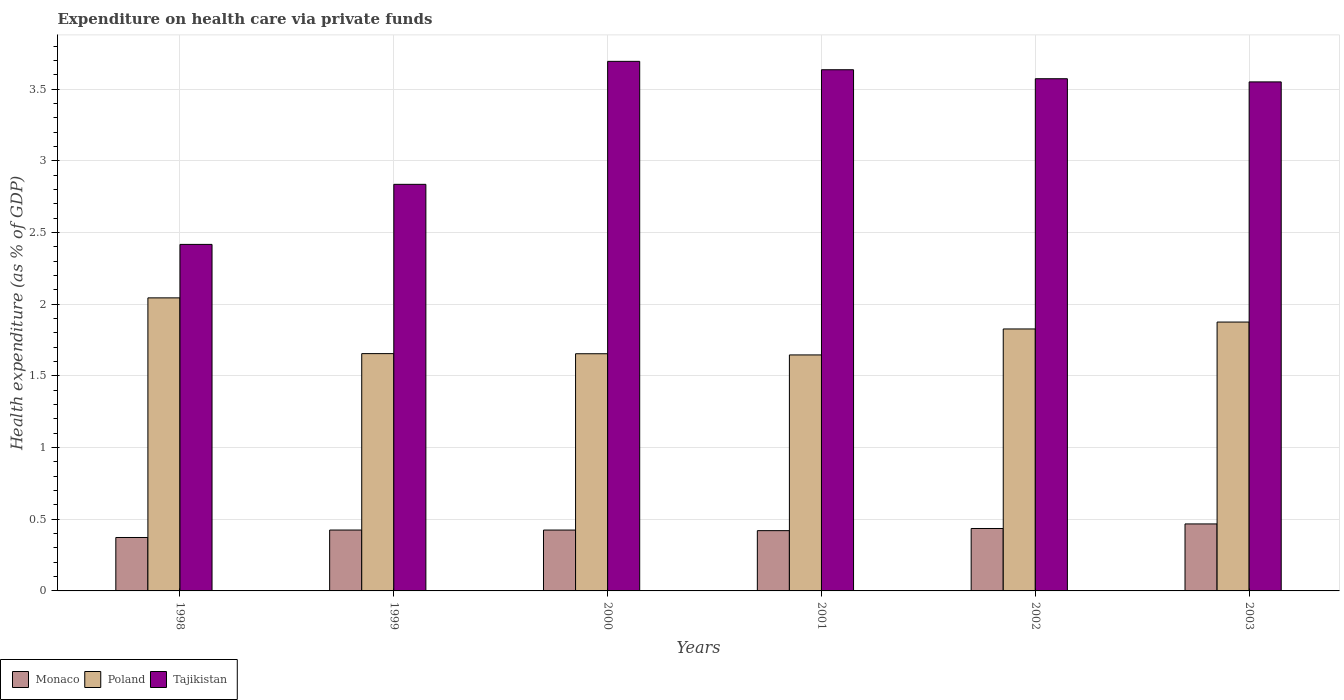How many groups of bars are there?
Your answer should be compact. 6. Are the number of bars per tick equal to the number of legend labels?
Ensure brevity in your answer.  Yes. Are the number of bars on each tick of the X-axis equal?
Give a very brief answer. Yes. How many bars are there on the 2nd tick from the right?
Your answer should be compact. 3. In how many cases, is the number of bars for a given year not equal to the number of legend labels?
Give a very brief answer. 0. What is the expenditure made on health care in Tajikistan in 2002?
Your response must be concise. 3.57. Across all years, what is the maximum expenditure made on health care in Poland?
Your answer should be very brief. 2.04. Across all years, what is the minimum expenditure made on health care in Tajikistan?
Your response must be concise. 2.42. In which year was the expenditure made on health care in Poland minimum?
Offer a terse response. 2001. What is the total expenditure made on health care in Monaco in the graph?
Offer a terse response. 2.55. What is the difference between the expenditure made on health care in Tajikistan in 1999 and that in 2000?
Your response must be concise. -0.86. What is the difference between the expenditure made on health care in Monaco in 2000 and the expenditure made on health care in Tajikistan in 1999?
Your response must be concise. -2.41. What is the average expenditure made on health care in Tajikistan per year?
Make the answer very short. 3.28. In the year 2001, what is the difference between the expenditure made on health care in Tajikistan and expenditure made on health care in Poland?
Your response must be concise. 1.99. In how many years, is the expenditure made on health care in Tajikistan greater than 0.8 %?
Your answer should be compact. 6. What is the ratio of the expenditure made on health care in Poland in 1999 to that in 2001?
Offer a very short reply. 1.01. Is the difference between the expenditure made on health care in Tajikistan in 2000 and 2001 greater than the difference between the expenditure made on health care in Poland in 2000 and 2001?
Your answer should be very brief. Yes. What is the difference between the highest and the second highest expenditure made on health care in Poland?
Your answer should be very brief. 0.17. What is the difference between the highest and the lowest expenditure made on health care in Tajikistan?
Your answer should be very brief. 1.28. In how many years, is the expenditure made on health care in Tajikistan greater than the average expenditure made on health care in Tajikistan taken over all years?
Keep it short and to the point. 4. Is the sum of the expenditure made on health care in Poland in 1999 and 2002 greater than the maximum expenditure made on health care in Tajikistan across all years?
Keep it short and to the point. No. What does the 1st bar from the left in 2000 represents?
Offer a terse response. Monaco. What does the 1st bar from the right in 1998 represents?
Your answer should be compact. Tajikistan. Are all the bars in the graph horizontal?
Give a very brief answer. No. How many years are there in the graph?
Your answer should be very brief. 6. What is the difference between two consecutive major ticks on the Y-axis?
Your answer should be very brief. 0.5. How are the legend labels stacked?
Ensure brevity in your answer.  Horizontal. What is the title of the graph?
Provide a succinct answer. Expenditure on health care via private funds. Does "Romania" appear as one of the legend labels in the graph?
Provide a succinct answer. No. What is the label or title of the X-axis?
Offer a very short reply. Years. What is the label or title of the Y-axis?
Offer a very short reply. Health expenditure (as % of GDP). What is the Health expenditure (as % of GDP) in Monaco in 1998?
Your response must be concise. 0.37. What is the Health expenditure (as % of GDP) of Poland in 1998?
Offer a very short reply. 2.04. What is the Health expenditure (as % of GDP) of Tajikistan in 1998?
Your response must be concise. 2.42. What is the Health expenditure (as % of GDP) of Monaco in 1999?
Make the answer very short. 0.42. What is the Health expenditure (as % of GDP) of Poland in 1999?
Provide a short and direct response. 1.66. What is the Health expenditure (as % of GDP) of Tajikistan in 1999?
Your answer should be very brief. 2.84. What is the Health expenditure (as % of GDP) of Monaco in 2000?
Provide a succinct answer. 0.42. What is the Health expenditure (as % of GDP) in Poland in 2000?
Offer a very short reply. 1.65. What is the Health expenditure (as % of GDP) of Tajikistan in 2000?
Offer a terse response. 3.69. What is the Health expenditure (as % of GDP) in Monaco in 2001?
Offer a very short reply. 0.42. What is the Health expenditure (as % of GDP) of Poland in 2001?
Keep it short and to the point. 1.65. What is the Health expenditure (as % of GDP) in Tajikistan in 2001?
Provide a short and direct response. 3.64. What is the Health expenditure (as % of GDP) in Monaco in 2002?
Make the answer very short. 0.44. What is the Health expenditure (as % of GDP) of Poland in 2002?
Your answer should be compact. 1.83. What is the Health expenditure (as % of GDP) of Tajikistan in 2002?
Your answer should be compact. 3.57. What is the Health expenditure (as % of GDP) of Monaco in 2003?
Your response must be concise. 0.47. What is the Health expenditure (as % of GDP) in Poland in 2003?
Your answer should be compact. 1.88. What is the Health expenditure (as % of GDP) in Tajikistan in 2003?
Make the answer very short. 3.55. Across all years, what is the maximum Health expenditure (as % of GDP) of Monaco?
Provide a short and direct response. 0.47. Across all years, what is the maximum Health expenditure (as % of GDP) of Poland?
Offer a terse response. 2.04. Across all years, what is the maximum Health expenditure (as % of GDP) of Tajikistan?
Ensure brevity in your answer.  3.69. Across all years, what is the minimum Health expenditure (as % of GDP) in Monaco?
Ensure brevity in your answer.  0.37. Across all years, what is the minimum Health expenditure (as % of GDP) of Poland?
Make the answer very short. 1.65. Across all years, what is the minimum Health expenditure (as % of GDP) in Tajikistan?
Provide a short and direct response. 2.42. What is the total Health expenditure (as % of GDP) of Monaco in the graph?
Give a very brief answer. 2.55. What is the total Health expenditure (as % of GDP) in Poland in the graph?
Provide a short and direct response. 10.7. What is the total Health expenditure (as % of GDP) of Tajikistan in the graph?
Give a very brief answer. 19.71. What is the difference between the Health expenditure (as % of GDP) of Monaco in 1998 and that in 1999?
Give a very brief answer. -0.05. What is the difference between the Health expenditure (as % of GDP) of Poland in 1998 and that in 1999?
Offer a terse response. 0.39. What is the difference between the Health expenditure (as % of GDP) of Tajikistan in 1998 and that in 1999?
Offer a terse response. -0.42. What is the difference between the Health expenditure (as % of GDP) in Monaco in 1998 and that in 2000?
Your answer should be very brief. -0.05. What is the difference between the Health expenditure (as % of GDP) in Poland in 1998 and that in 2000?
Keep it short and to the point. 0.39. What is the difference between the Health expenditure (as % of GDP) of Tajikistan in 1998 and that in 2000?
Offer a very short reply. -1.28. What is the difference between the Health expenditure (as % of GDP) in Monaco in 1998 and that in 2001?
Your response must be concise. -0.05. What is the difference between the Health expenditure (as % of GDP) of Poland in 1998 and that in 2001?
Offer a very short reply. 0.4. What is the difference between the Health expenditure (as % of GDP) of Tajikistan in 1998 and that in 2001?
Your response must be concise. -1.22. What is the difference between the Health expenditure (as % of GDP) in Monaco in 1998 and that in 2002?
Give a very brief answer. -0.06. What is the difference between the Health expenditure (as % of GDP) in Poland in 1998 and that in 2002?
Offer a terse response. 0.22. What is the difference between the Health expenditure (as % of GDP) in Tajikistan in 1998 and that in 2002?
Your response must be concise. -1.16. What is the difference between the Health expenditure (as % of GDP) in Monaco in 1998 and that in 2003?
Offer a terse response. -0.09. What is the difference between the Health expenditure (as % of GDP) in Poland in 1998 and that in 2003?
Provide a succinct answer. 0.17. What is the difference between the Health expenditure (as % of GDP) of Tajikistan in 1998 and that in 2003?
Your answer should be very brief. -1.13. What is the difference between the Health expenditure (as % of GDP) of Monaco in 1999 and that in 2000?
Offer a very short reply. 0. What is the difference between the Health expenditure (as % of GDP) of Poland in 1999 and that in 2000?
Ensure brevity in your answer.  0. What is the difference between the Health expenditure (as % of GDP) in Tajikistan in 1999 and that in 2000?
Make the answer very short. -0.86. What is the difference between the Health expenditure (as % of GDP) of Monaco in 1999 and that in 2001?
Provide a short and direct response. 0. What is the difference between the Health expenditure (as % of GDP) of Poland in 1999 and that in 2001?
Provide a succinct answer. 0.01. What is the difference between the Health expenditure (as % of GDP) of Tajikistan in 1999 and that in 2001?
Make the answer very short. -0.8. What is the difference between the Health expenditure (as % of GDP) in Monaco in 1999 and that in 2002?
Ensure brevity in your answer.  -0.01. What is the difference between the Health expenditure (as % of GDP) of Poland in 1999 and that in 2002?
Offer a terse response. -0.17. What is the difference between the Health expenditure (as % of GDP) of Tajikistan in 1999 and that in 2002?
Provide a short and direct response. -0.74. What is the difference between the Health expenditure (as % of GDP) in Monaco in 1999 and that in 2003?
Your response must be concise. -0.04. What is the difference between the Health expenditure (as % of GDP) of Poland in 1999 and that in 2003?
Your response must be concise. -0.22. What is the difference between the Health expenditure (as % of GDP) in Tajikistan in 1999 and that in 2003?
Keep it short and to the point. -0.71. What is the difference between the Health expenditure (as % of GDP) in Monaco in 2000 and that in 2001?
Keep it short and to the point. 0. What is the difference between the Health expenditure (as % of GDP) of Poland in 2000 and that in 2001?
Your response must be concise. 0.01. What is the difference between the Health expenditure (as % of GDP) in Tajikistan in 2000 and that in 2001?
Offer a terse response. 0.06. What is the difference between the Health expenditure (as % of GDP) of Monaco in 2000 and that in 2002?
Provide a succinct answer. -0.01. What is the difference between the Health expenditure (as % of GDP) in Poland in 2000 and that in 2002?
Make the answer very short. -0.17. What is the difference between the Health expenditure (as % of GDP) in Tajikistan in 2000 and that in 2002?
Ensure brevity in your answer.  0.12. What is the difference between the Health expenditure (as % of GDP) of Monaco in 2000 and that in 2003?
Give a very brief answer. -0.04. What is the difference between the Health expenditure (as % of GDP) of Poland in 2000 and that in 2003?
Provide a short and direct response. -0.22. What is the difference between the Health expenditure (as % of GDP) in Tajikistan in 2000 and that in 2003?
Keep it short and to the point. 0.14. What is the difference between the Health expenditure (as % of GDP) in Monaco in 2001 and that in 2002?
Offer a terse response. -0.01. What is the difference between the Health expenditure (as % of GDP) of Poland in 2001 and that in 2002?
Your answer should be very brief. -0.18. What is the difference between the Health expenditure (as % of GDP) of Tajikistan in 2001 and that in 2002?
Ensure brevity in your answer.  0.06. What is the difference between the Health expenditure (as % of GDP) of Monaco in 2001 and that in 2003?
Offer a terse response. -0.05. What is the difference between the Health expenditure (as % of GDP) in Poland in 2001 and that in 2003?
Keep it short and to the point. -0.23. What is the difference between the Health expenditure (as % of GDP) of Tajikistan in 2001 and that in 2003?
Make the answer very short. 0.08. What is the difference between the Health expenditure (as % of GDP) of Monaco in 2002 and that in 2003?
Give a very brief answer. -0.03. What is the difference between the Health expenditure (as % of GDP) of Poland in 2002 and that in 2003?
Provide a succinct answer. -0.05. What is the difference between the Health expenditure (as % of GDP) of Tajikistan in 2002 and that in 2003?
Offer a very short reply. 0.02. What is the difference between the Health expenditure (as % of GDP) in Monaco in 1998 and the Health expenditure (as % of GDP) in Poland in 1999?
Give a very brief answer. -1.28. What is the difference between the Health expenditure (as % of GDP) in Monaco in 1998 and the Health expenditure (as % of GDP) in Tajikistan in 1999?
Provide a short and direct response. -2.46. What is the difference between the Health expenditure (as % of GDP) of Poland in 1998 and the Health expenditure (as % of GDP) of Tajikistan in 1999?
Your answer should be very brief. -0.79. What is the difference between the Health expenditure (as % of GDP) in Monaco in 1998 and the Health expenditure (as % of GDP) in Poland in 2000?
Make the answer very short. -1.28. What is the difference between the Health expenditure (as % of GDP) of Monaco in 1998 and the Health expenditure (as % of GDP) of Tajikistan in 2000?
Your response must be concise. -3.32. What is the difference between the Health expenditure (as % of GDP) in Poland in 1998 and the Health expenditure (as % of GDP) in Tajikistan in 2000?
Offer a very short reply. -1.65. What is the difference between the Health expenditure (as % of GDP) of Monaco in 1998 and the Health expenditure (as % of GDP) of Poland in 2001?
Your answer should be very brief. -1.27. What is the difference between the Health expenditure (as % of GDP) of Monaco in 1998 and the Health expenditure (as % of GDP) of Tajikistan in 2001?
Offer a very short reply. -3.26. What is the difference between the Health expenditure (as % of GDP) of Poland in 1998 and the Health expenditure (as % of GDP) of Tajikistan in 2001?
Give a very brief answer. -1.59. What is the difference between the Health expenditure (as % of GDP) of Monaco in 1998 and the Health expenditure (as % of GDP) of Poland in 2002?
Keep it short and to the point. -1.45. What is the difference between the Health expenditure (as % of GDP) in Monaco in 1998 and the Health expenditure (as % of GDP) in Tajikistan in 2002?
Your response must be concise. -3.2. What is the difference between the Health expenditure (as % of GDP) of Poland in 1998 and the Health expenditure (as % of GDP) of Tajikistan in 2002?
Offer a terse response. -1.53. What is the difference between the Health expenditure (as % of GDP) of Monaco in 1998 and the Health expenditure (as % of GDP) of Poland in 2003?
Offer a very short reply. -1.5. What is the difference between the Health expenditure (as % of GDP) in Monaco in 1998 and the Health expenditure (as % of GDP) in Tajikistan in 2003?
Keep it short and to the point. -3.18. What is the difference between the Health expenditure (as % of GDP) in Poland in 1998 and the Health expenditure (as % of GDP) in Tajikistan in 2003?
Provide a succinct answer. -1.51. What is the difference between the Health expenditure (as % of GDP) in Monaco in 1999 and the Health expenditure (as % of GDP) in Poland in 2000?
Your answer should be compact. -1.23. What is the difference between the Health expenditure (as % of GDP) of Monaco in 1999 and the Health expenditure (as % of GDP) of Tajikistan in 2000?
Provide a succinct answer. -3.27. What is the difference between the Health expenditure (as % of GDP) of Poland in 1999 and the Health expenditure (as % of GDP) of Tajikistan in 2000?
Your response must be concise. -2.04. What is the difference between the Health expenditure (as % of GDP) in Monaco in 1999 and the Health expenditure (as % of GDP) in Poland in 2001?
Provide a short and direct response. -1.22. What is the difference between the Health expenditure (as % of GDP) of Monaco in 1999 and the Health expenditure (as % of GDP) of Tajikistan in 2001?
Provide a succinct answer. -3.21. What is the difference between the Health expenditure (as % of GDP) of Poland in 1999 and the Health expenditure (as % of GDP) of Tajikistan in 2001?
Provide a short and direct response. -1.98. What is the difference between the Health expenditure (as % of GDP) in Monaco in 1999 and the Health expenditure (as % of GDP) in Poland in 2002?
Give a very brief answer. -1.4. What is the difference between the Health expenditure (as % of GDP) in Monaco in 1999 and the Health expenditure (as % of GDP) in Tajikistan in 2002?
Your answer should be compact. -3.15. What is the difference between the Health expenditure (as % of GDP) in Poland in 1999 and the Health expenditure (as % of GDP) in Tajikistan in 2002?
Your answer should be compact. -1.92. What is the difference between the Health expenditure (as % of GDP) in Monaco in 1999 and the Health expenditure (as % of GDP) in Poland in 2003?
Provide a short and direct response. -1.45. What is the difference between the Health expenditure (as % of GDP) in Monaco in 1999 and the Health expenditure (as % of GDP) in Tajikistan in 2003?
Your answer should be very brief. -3.13. What is the difference between the Health expenditure (as % of GDP) in Poland in 1999 and the Health expenditure (as % of GDP) in Tajikistan in 2003?
Give a very brief answer. -1.9. What is the difference between the Health expenditure (as % of GDP) of Monaco in 2000 and the Health expenditure (as % of GDP) of Poland in 2001?
Offer a terse response. -1.22. What is the difference between the Health expenditure (as % of GDP) in Monaco in 2000 and the Health expenditure (as % of GDP) in Tajikistan in 2001?
Provide a succinct answer. -3.21. What is the difference between the Health expenditure (as % of GDP) of Poland in 2000 and the Health expenditure (as % of GDP) of Tajikistan in 2001?
Provide a succinct answer. -1.98. What is the difference between the Health expenditure (as % of GDP) in Monaco in 2000 and the Health expenditure (as % of GDP) in Poland in 2002?
Give a very brief answer. -1.4. What is the difference between the Health expenditure (as % of GDP) in Monaco in 2000 and the Health expenditure (as % of GDP) in Tajikistan in 2002?
Make the answer very short. -3.15. What is the difference between the Health expenditure (as % of GDP) of Poland in 2000 and the Health expenditure (as % of GDP) of Tajikistan in 2002?
Provide a short and direct response. -1.92. What is the difference between the Health expenditure (as % of GDP) of Monaco in 2000 and the Health expenditure (as % of GDP) of Poland in 2003?
Your answer should be very brief. -1.45. What is the difference between the Health expenditure (as % of GDP) in Monaco in 2000 and the Health expenditure (as % of GDP) in Tajikistan in 2003?
Provide a short and direct response. -3.13. What is the difference between the Health expenditure (as % of GDP) of Poland in 2000 and the Health expenditure (as % of GDP) of Tajikistan in 2003?
Give a very brief answer. -1.9. What is the difference between the Health expenditure (as % of GDP) of Monaco in 2001 and the Health expenditure (as % of GDP) of Poland in 2002?
Your answer should be very brief. -1.41. What is the difference between the Health expenditure (as % of GDP) of Monaco in 2001 and the Health expenditure (as % of GDP) of Tajikistan in 2002?
Your answer should be compact. -3.15. What is the difference between the Health expenditure (as % of GDP) in Poland in 2001 and the Health expenditure (as % of GDP) in Tajikistan in 2002?
Offer a very short reply. -1.93. What is the difference between the Health expenditure (as % of GDP) in Monaco in 2001 and the Health expenditure (as % of GDP) in Poland in 2003?
Your answer should be compact. -1.46. What is the difference between the Health expenditure (as % of GDP) in Monaco in 2001 and the Health expenditure (as % of GDP) in Tajikistan in 2003?
Provide a short and direct response. -3.13. What is the difference between the Health expenditure (as % of GDP) in Poland in 2001 and the Health expenditure (as % of GDP) in Tajikistan in 2003?
Your response must be concise. -1.9. What is the difference between the Health expenditure (as % of GDP) of Monaco in 2002 and the Health expenditure (as % of GDP) of Poland in 2003?
Give a very brief answer. -1.44. What is the difference between the Health expenditure (as % of GDP) in Monaco in 2002 and the Health expenditure (as % of GDP) in Tajikistan in 2003?
Ensure brevity in your answer.  -3.12. What is the difference between the Health expenditure (as % of GDP) of Poland in 2002 and the Health expenditure (as % of GDP) of Tajikistan in 2003?
Provide a short and direct response. -1.72. What is the average Health expenditure (as % of GDP) of Monaco per year?
Provide a succinct answer. 0.42. What is the average Health expenditure (as % of GDP) of Poland per year?
Offer a very short reply. 1.78. What is the average Health expenditure (as % of GDP) in Tajikistan per year?
Keep it short and to the point. 3.28. In the year 1998, what is the difference between the Health expenditure (as % of GDP) of Monaco and Health expenditure (as % of GDP) of Poland?
Give a very brief answer. -1.67. In the year 1998, what is the difference between the Health expenditure (as % of GDP) in Monaco and Health expenditure (as % of GDP) in Tajikistan?
Your answer should be compact. -2.04. In the year 1998, what is the difference between the Health expenditure (as % of GDP) in Poland and Health expenditure (as % of GDP) in Tajikistan?
Keep it short and to the point. -0.37. In the year 1999, what is the difference between the Health expenditure (as % of GDP) of Monaco and Health expenditure (as % of GDP) of Poland?
Make the answer very short. -1.23. In the year 1999, what is the difference between the Health expenditure (as % of GDP) in Monaco and Health expenditure (as % of GDP) in Tajikistan?
Offer a terse response. -2.41. In the year 1999, what is the difference between the Health expenditure (as % of GDP) of Poland and Health expenditure (as % of GDP) of Tajikistan?
Your response must be concise. -1.18. In the year 2000, what is the difference between the Health expenditure (as % of GDP) in Monaco and Health expenditure (as % of GDP) in Poland?
Your response must be concise. -1.23. In the year 2000, what is the difference between the Health expenditure (as % of GDP) of Monaco and Health expenditure (as % of GDP) of Tajikistan?
Offer a terse response. -3.27. In the year 2000, what is the difference between the Health expenditure (as % of GDP) of Poland and Health expenditure (as % of GDP) of Tajikistan?
Make the answer very short. -2.04. In the year 2001, what is the difference between the Health expenditure (as % of GDP) in Monaco and Health expenditure (as % of GDP) in Poland?
Ensure brevity in your answer.  -1.23. In the year 2001, what is the difference between the Health expenditure (as % of GDP) of Monaco and Health expenditure (as % of GDP) of Tajikistan?
Make the answer very short. -3.22. In the year 2001, what is the difference between the Health expenditure (as % of GDP) in Poland and Health expenditure (as % of GDP) in Tajikistan?
Ensure brevity in your answer.  -1.99. In the year 2002, what is the difference between the Health expenditure (as % of GDP) in Monaco and Health expenditure (as % of GDP) in Poland?
Keep it short and to the point. -1.39. In the year 2002, what is the difference between the Health expenditure (as % of GDP) in Monaco and Health expenditure (as % of GDP) in Tajikistan?
Offer a very short reply. -3.14. In the year 2002, what is the difference between the Health expenditure (as % of GDP) of Poland and Health expenditure (as % of GDP) of Tajikistan?
Make the answer very short. -1.75. In the year 2003, what is the difference between the Health expenditure (as % of GDP) of Monaco and Health expenditure (as % of GDP) of Poland?
Your answer should be very brief. -1.41. In the year 2003, what is the difference between the Health expenditure (as % of GDP) in Monaco and Health expenditure (as % of GDP) in Tajikistan?
Provide a short and direct response. -3.08. In the year 2003, what is the difference between the Health expenditure (as % of GDP) in Poland and Health expenditure (as % of GDP) in Tajikistan?
Provide a succinct answer. -1.68. What is the ratio of the Health expenditure (as % of GDP) in Monaco in 1998 to that in 1999?
Offer a very short reply. 0.88. What is the ratio of the Health expenditure (as % of GDP) of Poland in 1998 to that in 1999?
Provide a short and direct response. 1.23. What is the ratio of the Health expenditure (as % of GDP) of Tajikistan in 1998 to that in 1999?
Your response must be concise. 0.85. What is the ratio of the Health expenditure (as % of GDP) of Monaco in 1998 to that in 2000?
Provide a short and direct response. 0.88. What is the ratio of the Health expenditure (as % of GDP) in Poland in 1998 to that in 2000?
Make the answer very short. 1.24. What is the ratio of the Health expenditure (as % of GDP) of Tajikistan in 1998 to that in 2000?
Your answer should be compact. 0.65. What is the ratio of the Health expenditure (as % of GDP) in Monaco in 1998 to that in 2001?
Keep it short and to the point. 0.89. What is the ratio of the Health expenditure (as % of GDP) of Poland in 1998 to that in 2001?
Your answer should be compact. 1.24. What is the ratio of the Health expenditure (as % of GDP) of Tajikistan in 1998 to that in 2001?
Give a very brief answer. 0.66. What is the ratio of the Health expenditure (as % of GDP) of Monaco in 1998 to that in 2002?
Keep it short and to the point. 0.86. What is the ratio of the Health expenditure (as % of GDP) of Poland in 1998 to that in 2002?
Provide a succinct answer. 1.12. What is the ratio of the Health expenditure (as % of GDP) of Tajikistan in 1998 to that in 2002?
Keep it short and to the point. 0.68. What is the ratio of the Health expenditure (as % of GDP) of Monaco in 1998 to that in 2003?
Your answer should be very brief. 0.8. What is the ratio of the Health expenditure (as % of GDP) in Poland in 1998 to that in 2003?
Provide a succinct answer. 1.09. What is the ratio of the Health expenditure (as % of GDP) in Tajikistan in 1998 to that in 2003?
Offer a very short reply. 0.68. What is the ratio of the Health expenditure (as % of GDP) of Poland in 1999 to that in 2000?
Your answer should be compact. 1. What is the ratio of the Health expenditure (as % of GDP) in Tajikistan in 1999 to that in 2000?
Give a very brief answer. 0.77. What is the ratio of the Health expenditure (as % of GDP) in Tajikistan in 1999 to that in 2001?
Your answer should be compact. 0.78. What is the ratio of the Health expenditure (as % of GDP) of Monaco in 1999 to that in 2002?
Offer a terse response. 0.98. What is the ratio of the Health expenditure (as % of GDP) of Poland in 1999 to that in 2002?
Your response must be concise. 0.91. What is the ratio of the Health expenditure (as % of GDP) in Tajikistan in 1999 to that in 2002?
Your response must be concise. 0.79. What is the ratio of the Health expenditure (as % of GDP) in Monaco in 1999 to that in 2003?
Keep it short and to the point. 0.91. What is the ratio of the Health expenditure (as % of GDP) in Poland in 1999 to that in 2003?
Provide a succinct answer. 0.88. What is the ratio of the Health expenditure (as % of GDP) in Tajikistan in 1999 to that in 2003?
Provide a succinct answer. 0.8. What is the ratio of the Health expenditure (as % of GDP) in Monaco in 2000 to that in 2001?
Provide a succinct answer. 1.01. What is the ratio of the Health expenditure (as % of GDP) of Tajikistan in 2000 to that in 2001?
Your answer should be compact. 1.02. What is the ratio of the Health expenditure (as % of GDP) of Poland in 2000 to that in 2002?
Provide a short and direct response. 0.91. What is the ratio of the Health expenditure (as % of GDP) of Tajikistan in 2000 to that in 2002?
Make the answer very short. 1.03. What is the ratio of the Health expenditure (as % of GDP) of Monaco in 2000 to that in 2003?
Make the answer very short. 0.91. What is the ratio of the Health expenditure (as % of GDP) in Poland in 2000 to that in 2003?
Keep it short and to the point. 0.88. What is the ratio of the Health expenditure (as % of GDP) of Tajikistan in 2000 to that in 2003?
Offer a very short reply. 1.04. What is the ratio of the Health expenditure (as % of GDP) in Monaco in 2001 to that in 2002?
Your response must be concise. 0.97. What is the ratio of the Health expenditure (as % of GDP) of Poland in 2001 to that in 2002?
Ensure brevity in your answer.  0.9. What is the ratio of the Health expenditure (as % of GDP) of Tajikistan in 2001 to that in 2002?
Your answer should be very brief. 1.02. What is the ratio of the Health expenditure (as % of GDP) of Monaco in 2001 to that in 2003?
Provide a succinct answer. 0.9. What is the ratio of the Health expenditure (as % of GDP) of Poland in 2001 to that in 2003?
Your response must be concise. 0.88. What is the ratio of the Health expenditure (as % of GDP) in Tajikistan in 2001 to that in 2003?
Offer a terse response. 1.02. What is the ratio of the Health expenditure (as % of GDP) in Monaco in 2002 to that in 2003?
Your answer should be very brief. 0.93. What is the ratio of the Health expenditure (as % of GDP) in Poland in 2002 to that in 2003?
Make the answer very short. 0.97. What is the ratio of the Health expenditure (as % of GDP) in Tajikistan in 2002 to that in 2003?
Keep it short and to the point. 1.01. What is the difference between the highest and the second highest Health expenditure (as % of GDP) of Monaco?
Your response must be concise. 0.03. What is the difference between the highest and the second highest Health expenditure (as % of GDP) of Poland?
Ensure brevity in your answer.  0.17. What is the difference between the highest and the second highest Health expenditure (as % of GDP) in Tajikistan?
Offer a very short reply. 0.06. What is the difference between the highest and the lowest Health expenditure (as % of GDP) of Monaco?
Make the answer very short. 0.09. What is the difference between the highest and the lowest Health expenditure (as % of GDP) of Poland?
Offer a very short reply. 0.4. What is the difference between the highest and the lowest Health expenditure (as % of GDP) in Tajikistan?
Offer a terse response. 1.28. 